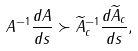<formula> <loc_0><loc_0><loc_500><loc_500>A ^ { - 1 } \frac { d A } { d s } \succ \widetilde { A } _ { c } ^ { - 1 } \frac { d \widetilde { A } _ { c } } { d s } , \\</formula> 